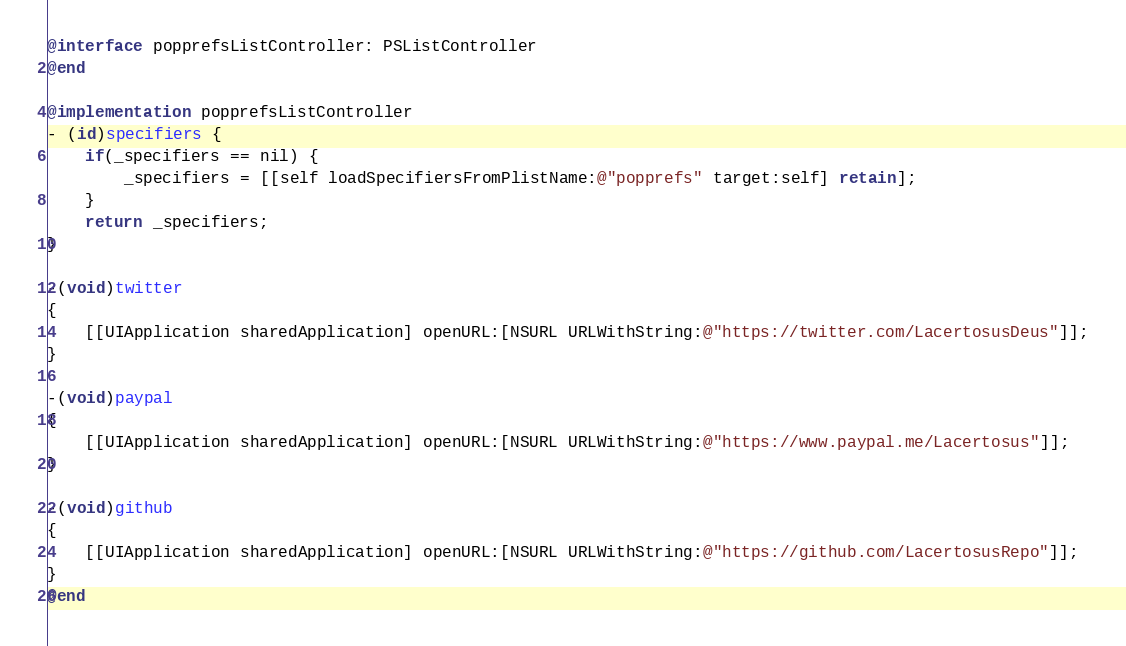<code> <loc_0><loc_0><loc_500><loc_500><_ObjectiveC_>
@interface popprefsListController: PSListController
@end

@implementation popprefsListController
- (id)specifiers {
	if(_specifiers == nil) {
		_specifiers = [[self loadSpecifiersFromPlistName:@"popprefs" target:self] retain];
	}
	return _specifiers;
}

-(void)twitter
{
	[[UIApplication sharedApplication] openURL:[NSURL URLWithString:@"https://twitter.com/LacertosusDeus"]];
}

-(void)paypal
{
	[[UIApplication sharedApplication] openURL:[NSURL URLWithString:@"https://www.paypal.me/Lacertosus"]];
}

-(void)github
{
	[[UIApplication sharedApplication] openURL:[NSURL URLWithString:@"https://github.com/LacertosusRepo"]];
}
@end
</code> 